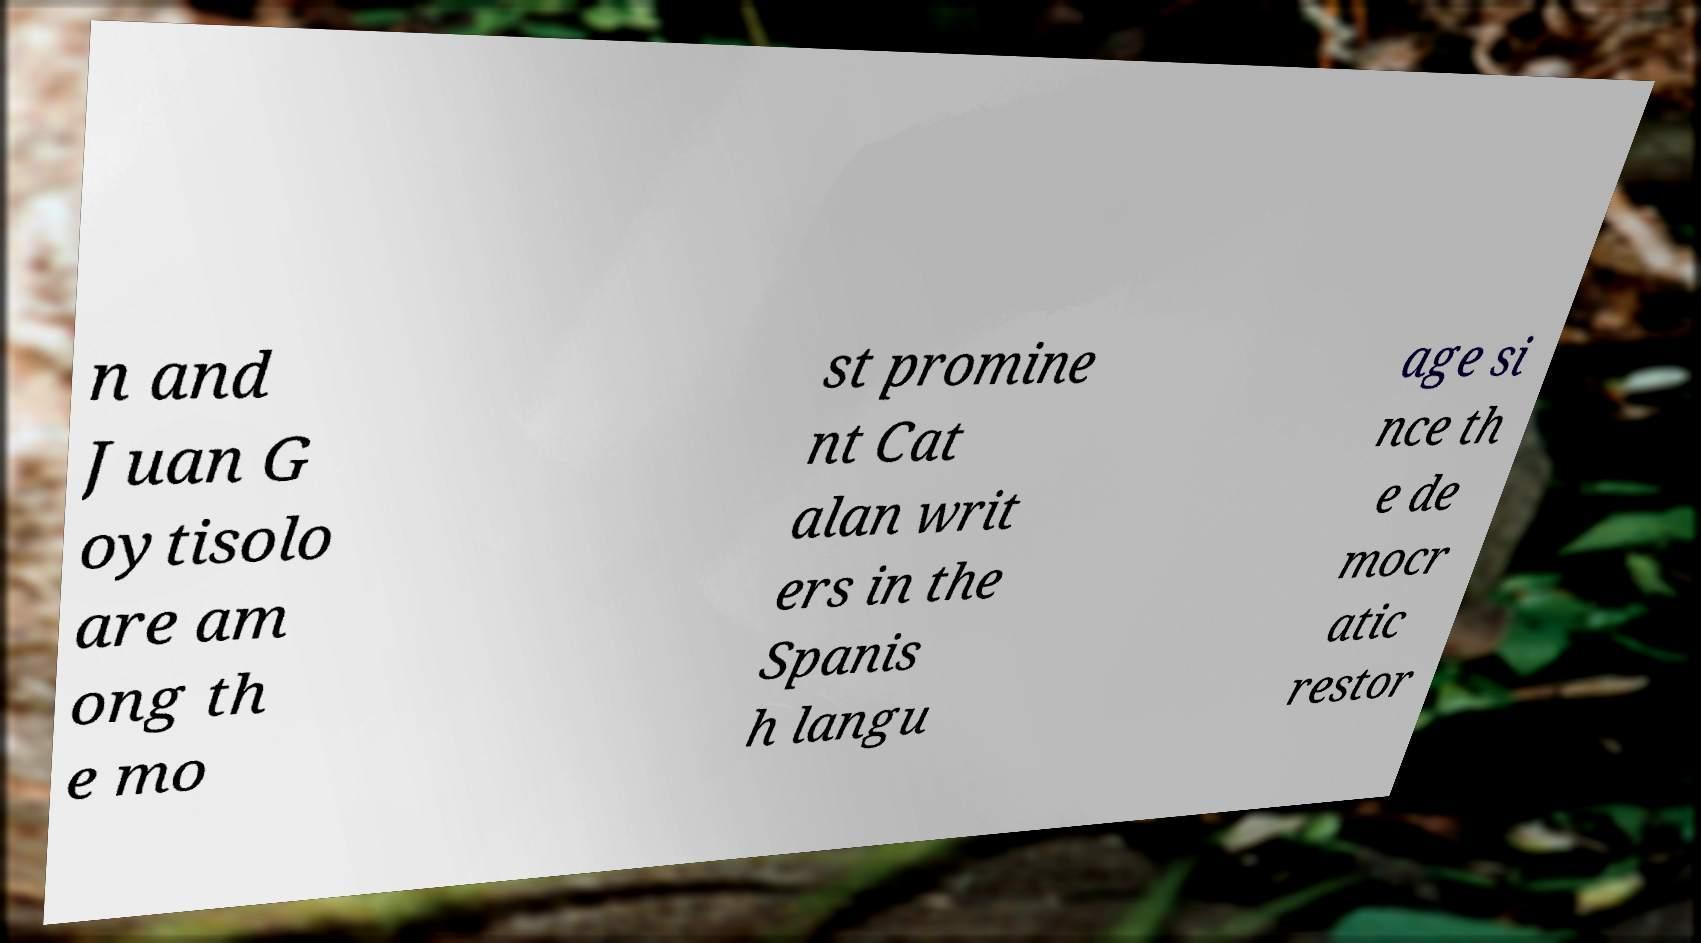For documentation purposes, I need the text within this image transcribed. Could you provide that? n and Juan G oytisolo are am ong th e mo st promine nt Cat alan writ ers in the Spanis h langu age si nce th e de mocr atic restor 